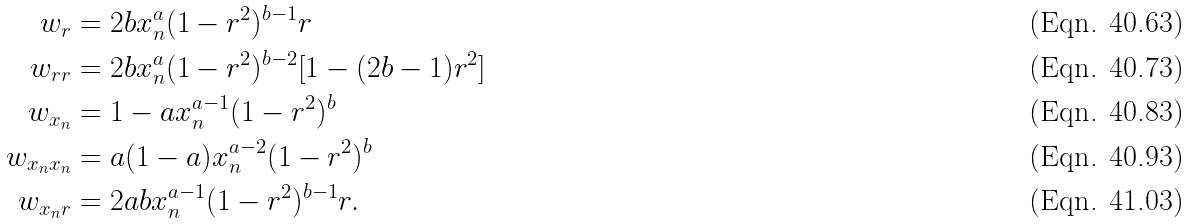Convert formula to latex. <formula><loc_0><loc_0><loc_500><loc_500>w _ { r } & = 2 b x _ { n } ^ { a } ( 1 - r ^ { 2 } ) ^ { b - 1 } r \\ w _ { r r } & = 2 b x _ { n } ^ { a } ( 1 - r ^ { 2 } ) ^ { b - 2 } [ 1 - ( 2 b - 1 ) r ^ { 2 } ] \\ w _ { x _ { n } } & = 1 - a x _ { n } ^ { a - 1 } ( 1 - r ^ { 2 } ) ^ { b } \\ w _ { x _ { n } x _ { n } } & = a ( 1 - a ) x _ { n } ^ { a - 2 } ( 1 - r ^ { 2 } ) ^ { b } \\ w _ { x _ { n } r } & = 2 a b x _ { n } ^ { a - 1 } ( 1 - r ^ { 2 } ) ^ { b - 1 } r .</formula> 